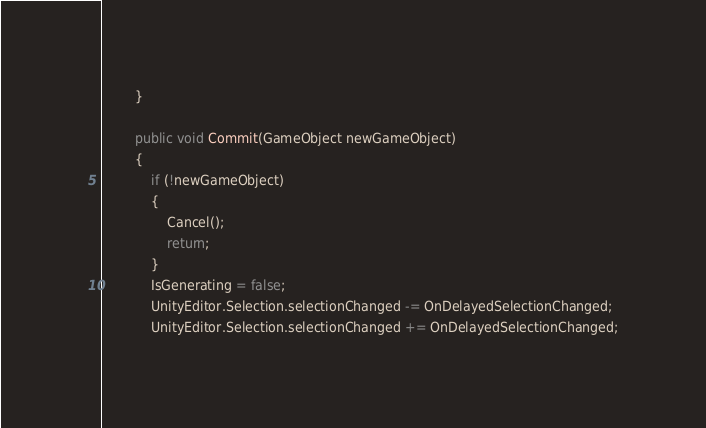Convert code to text. <code><loc_0><loc_0><loc_500><loc_500><_C#_>        }

        public void Commit(GameObject newGameObject)
        {
            if (!newGameObject)
            {
                Cancel();
                return;
            }
            IsGenerating = false;
            UnityEditor.Selection.selectionChanged -= OnDelayedSelectionChanged;
            UnityEditor.Selection.selectionChanged += OnDelayedSelectionChanged;</code> 